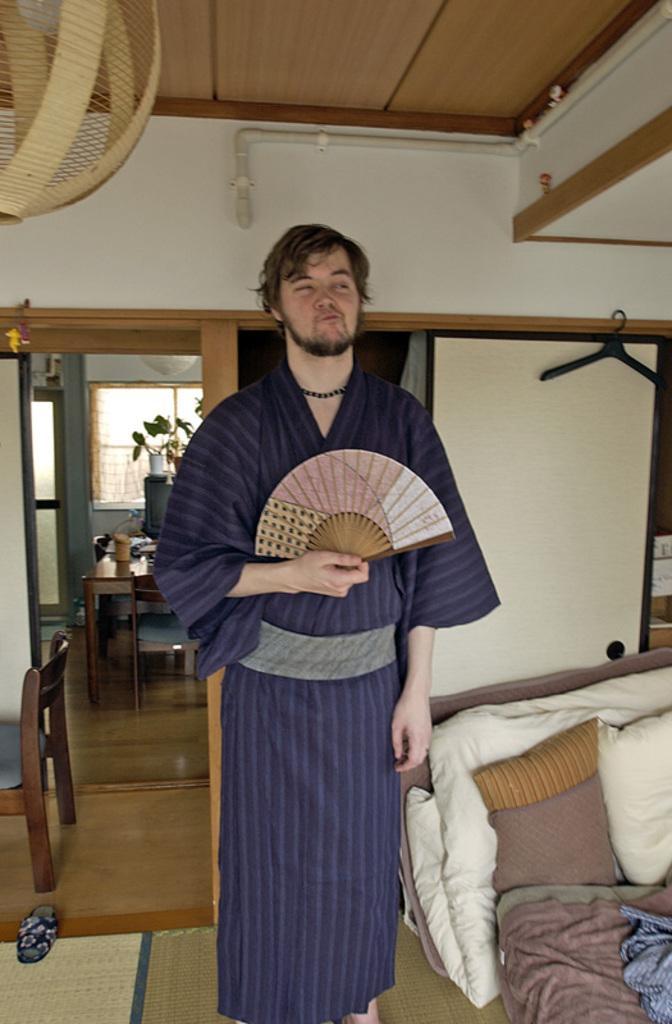Could you give a brief overview of what you see in this image? He is a man standing and holding folding fan. On the right there is a pillow,cloth and a bed. Behind this person there is a window,water plant,table,chair and a hanger. 